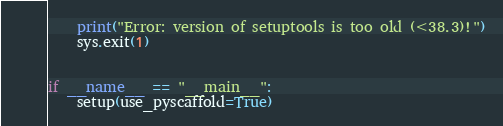<code> <loc_0><loc_0><loc_500><loc_500><_Python_>    print("Error: version of setuptools is too old (<38.3)!")
    sys.exit(1)


if __name__ == "__main__":
    setup(use_pyscaffold=True)
</code> 